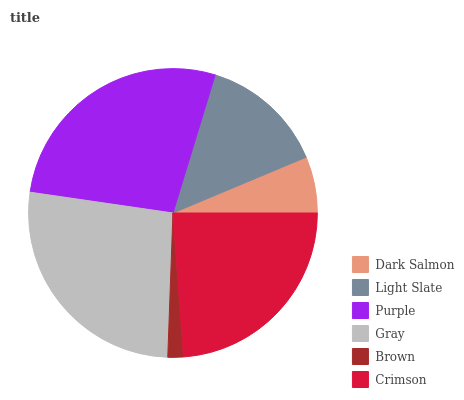Is Brown the minimum?
Answer yes or no. Yes. Is Purple the maximum?
Answer yes or no. Yes. Is Light Slate the minimum?
Answer yes or no. No. Is Light Slate the maximum?
Answer yes or no. No. Is Light Slate greater than Dark Salmon?
Answer yes or no. Yes. Is Dark Salmon less than Light Slate?
Answer yes or no. Yes. Is Dark Salmon greater than Light Slate?
Answer yes or no. No. Is Light Slate less than Dark Salmon?
Answer yes or no. No. Is Crimson the high median?
Answer yes or no. Yes. Is Light Slate the low median?
Answer yes or no. Yes. Is Gray the high median?
Answer yes or no. No. Is Dark Salmon the low median?
Answer yes or no. No. 